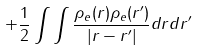<formula> <loc_0><loc_0><loc_500><loc_500>+ \frac { 1 } { 2 } \int \int \frac { \rho _ { e } ( r ) \rho _ { e } ( r ^ { \prime } ) } { | r - r ^ { \prime } | } d r d r ^ { \prime }</formula> 